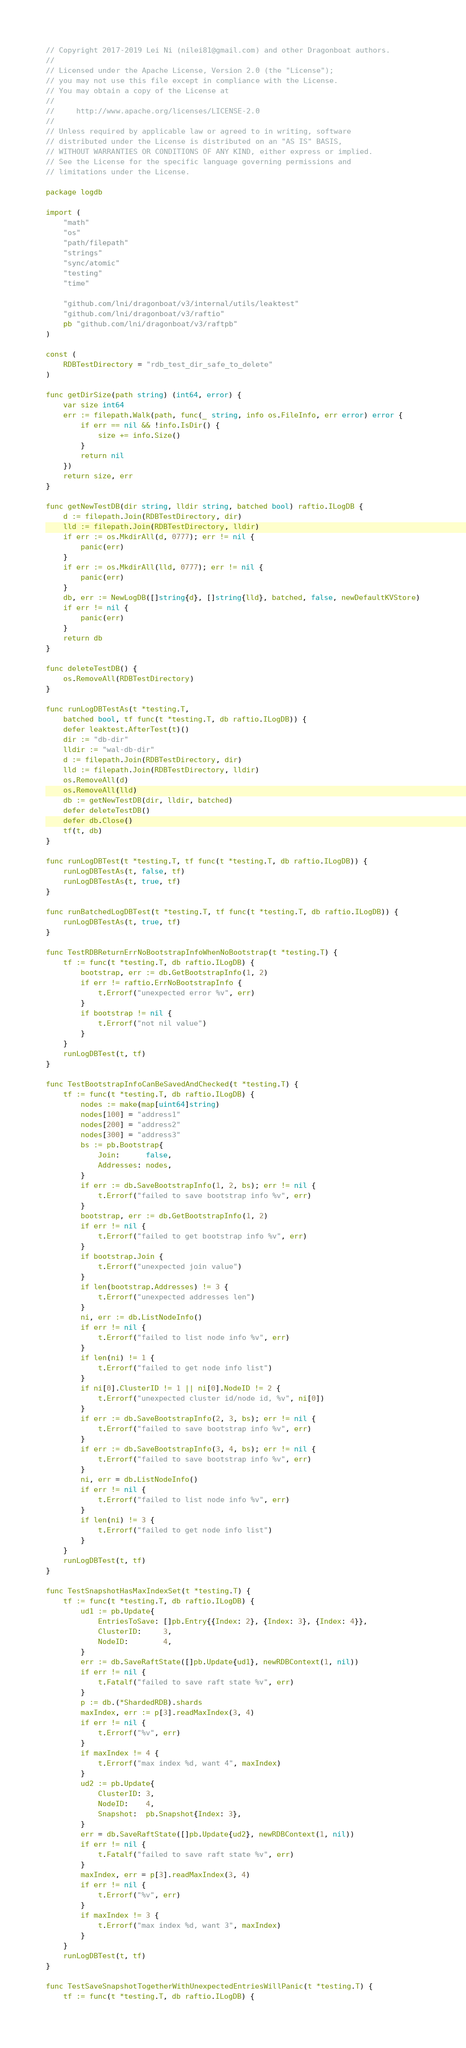<code> <loc_0><loc_0><loc_500><loc_500><_Go_>// Copyright 2017-2019 Lei Ni (nilei81@gmail.com) and other Dragonboat authors.
//
// Licensed under the Apache License, Version 2.0 (the "License");
// you may not use this file except in compliance with the License.
// You may obtain a copy of the License at
//
//     http://www.apache.org/licenses/LICENSE-2.0
//
// Unless required by applicable law or agreed to in writing, software
// distributed under the License is distributed on an "AS IS" BASIS,
// WITHOUT WARRANTIES OR CONDITIONS OF ANY KIND, either express or implied.
// See the License for the specific language governing permissions and
// limitations under the License.

package logdb

import (
	"math"
	"os"
	"path/filepath"
	"strings"
	"sync/atomic"
	"testing"
	"time"

	"github.com/lni/dragonboat/v3/internal/utils/leaktest"
	"github.com/lni/dragonboat/v3/raftio"
	pb "github.com/lni/dragonboat/v3/raftpb"
)

const (
	RDBTestDirectory = "rdb_test_dir_safe_to_delete"
)

func getDirSize(path string) (int64, error) {
	var size int64
	err := filepath.Walk(path, func(_ string, info os.FileInfo, err error) error {
		if err == nil && !info.IsDir() {
			size += info.Size()
		}
		return nil
	})
	return size, err
}

func getNewTestDB(dir string, lldir string, batched bool) raftio.ILogDB {
	d := filepath.Join(RDBTestDirectory, dir)
	lld := filepath.Join(RDBTestDirectory, lldir)
	if err := os.MkdirAll(d, 0777); err != nil {
		panic(err)
	}
	if err := os.MkdirAll(lld, 0777); err != nil {
		panic(err)
	}
	db, err := NewLogDB([]string{d}, []string{lld}, batched, false, newDefaultKVStore)
	if err != nil {
		panic(err)
	}
	return db
}

func deleteTestDB() {
	os.RemoveAll(RDBTestDirectory)
}

func runLogDBTestAs(t *testing.T,
	batched bool, tf func(t *testing.T, db raftio.ILogDB)) {
	defer leaktest.AfterTest(t)()
	dir := "db-dir"
	lldir := "wal-db-dir"
	d := filepath.Join(RDBTestDirectory, dir)
	lld := filepath.Join(RDBTestDirectory, lldir)
	os.RemoveAll(d)
	os.RemoveAll(lld)
	db := getNewTestDB(dir, lldir, batched)
	defer deleteTestDB()
	defer db.Close()
	tf(t, db)
}

func runLogDBTest(t *testing.T, tf func(t *testing.T, db raftio.ILogDB)) {
	runLogDBTestAs(t, false, tf)
	runLogDBTestAs(t, true, tf)
}

func runBatchedLogDBTest(t *testing.T, tf func(t *testing.T, db raftio.ILogDB)) {
	runLogDBTestAs(t, true, tf)
}

func TestRDBReturnErrNoBootstrapInfoWhenNoBootstrap(t *testing.T) {
	tf := func(t *testing.T, db raftio.ILogDB) {
		bootstrap, err := db.GetBootstrapInfo(1, 2)
		if err != raftio.ErrNoBootstrapInfo {
			t.Errorf("unexpected error %v", err)
		}
		if bootstrap != nil {
			t.Errorf("not nil value")
		}
	}
	runLogDBTest(t, tf)
}

func TestBootstrapInfoCanBeSavedAndChecked(t *testing.T) {
	tf := func(t *testing.T, db raftio.ILogDB) {
		nodes := make(map[uint64]string)
		nodes[100] = "address1"
		nodes[200] = "address2"
		nodes[300] = "address3"
		bs := pb.Bootstrap{
			Join:      false,
			Addresses: nodes,
		}
		if err := db.SaveBootstrapInfo(1, 2, bs); err != nil {
			t.Errorf("failed to save bootstrap info %v", err)
		}
		bootstrap, err := db.GetBootstrapInfo(1, 2)
		if err != nil {
			t.Errorf("failed to get bootstrap info %v", err)
		}
		if bootstrap.Join {
			t.Errorf("unexpected join value")
		}
		if len(bootstrap.Addresses) != 3 {
			t.Errorf("unexpected addresses len")
		}
		ni, err := db.ListNodeInfo()
		if err != nil {
			t.Errorf("failed to list node info %v", err)
		}
		if len(ni) != 1 {
			t.Errorf("failed to get node info list")
		}
		if ni[0].ClusterID != 1 || ni[0].NodeID != 2 {
			t.Errorf("unexpected cluster id/node id, %v", ni[0])
		}
		if err := db.SaveBootstrapInfo(2, 3, bs); err != nil {
			t.Errorf("failed to save bootstrap info %v", err)
		}
		if err := db.SaveBootstrapInfo(3, 4, bs); err != nil {
			t.Errorf("failed to save bootstrap info %v", err)
		}
		ni, err = db.ListNodeInfo()
		if err != nil {
			t.Errorf("failed to list node info %v", err)
		}
		if len(ni) != 3 {
			t.Errorf("failed to get node info list")
		}
	}
	runLogDBTest(t, tf)
}

func TestSnapshotHasMaxIndexSet(t *testing.T) {
	tf := func(t *testing.T, db raftio.ILogDB) {
		ud1 := pb.Update{
			EntriesToSave: []pb.Entry{{Index: 2}, {Index: 3}, {Index: 4}},
			ClusterID:     3,
			NodeID:        4,
		}
		err := db.SaveRaftState([]pb.Update{ud1}, newRDBContext(1, nil))
		if err != nil {
			t.Fatalf("failed to save raft state %v", err)
		}
		p := db.(*ShardedRDB).shards
		maxIndex, err := p[3].readMaxIndex(3, 4)
		if err != nil {
			t.Errorf("%v", err)
		}
		if maxIndex != 4 {
			t.Errorf("max index %d, want 4", maxIndex)
		}
		ud2 := pb.Update{
			ClusterID: 3,
			NodeID:    4,
			Snapshot:  pb.Snapshot{Index: 3},
		}
		err = db.SaveRaftState([]pb.Update{ud2}, newRDBContext(1, nil))
		if err != nil {
			t.Fatalf("failed to save raft state %v", err)
		}
		maxIndex, err = p[3].readMaxIndex(3, 4)
		if err != nil {
			t.Errorf("%v", err)
		}
		if maxIndex != 3 {
			t.Errorf("max index %d, want 3", maxIndex)
		}
	}
	runLogDBTest(t, tf)
}

func TestSaveSnapshotTogetherWithUnexpectedEntriesWillPanic(t *testing.T) {
	tf := func(t *testing.T, db raftio.ILogDB) {</code> 